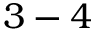<formula> <loc_0><loc_0><loc_500><loc_500>3 - 4</formula> 